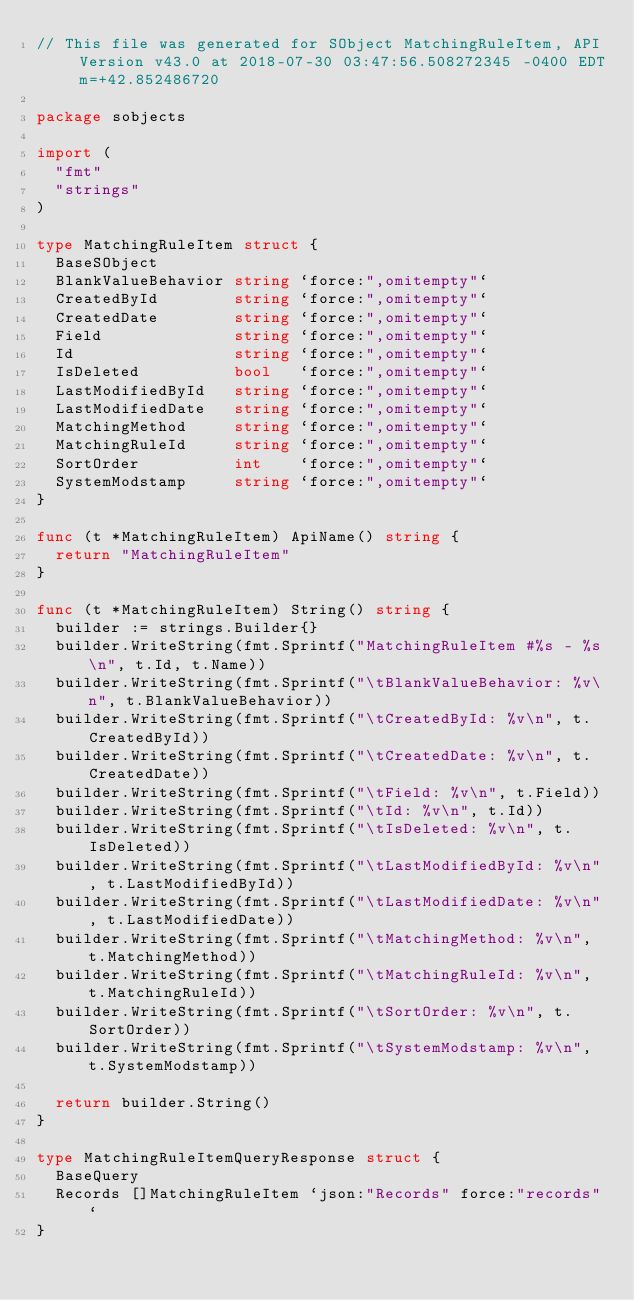Convert code to text. <code><loc_0><loc_0><loc_500><loc_500><_Go_>// This file was generated for SObject MatchingRuleItem, API Version v43.0 at 2018-07-30 03:47:56.508272345 -0400 EDT m=+42.852486720

package sobjects

import (
	"fmt"
	"strings"
)

type MatchingRuleItem struct {
	BaseSObject
	BlankValueBehavior string `force:",omitempty"`
	CreatedById        string `force:",omitempty"`
	CreatedDate        string `force:",omitempty"`
	Field              string `force:",omitempty"`
	Id                 string `force:",omitempty"`
	IsDeleted          bool   `force:",omitempty"`
	LastModifiedById   string `force:",omitempty"`
	LastModifiedDate   string `force:",omitempty"`
	MatchingMethod     string `force:",omitempty"`
	MatchingRuleId     string `force:",omitempty"`
	SortOrder          int    `force:",omitempty"`
	SystemModstamp     string `force:",omitempty"`
}

func (t *MatchingRuleItem) ApiName() string {
	return "MatchingRuleItem"
}

func (t *MatchingRuleItem) String() string {
	builder := strings.Builder{}
	builder.WriteString(fmt.Sprintf("MatchingRuleItem #%s - %s\n", t.Id, t.Name))
	builder.WriteString(fmt.Sprintf("\tBlankValueBehavior: %v\n", t.BlankValueBehavior))
	builder.WriteString(fmt.Sprintf("\tCreatedById: %v\n", t.CreatedById))
	builder.WriteString(fmt.Sprintf("\tCreatedDate: %v\n", t.CreatedDate))
	builder.WriteString(fmt.Sprintf("\tField: %v\n", t.Field))
	builder.WriteString(fmt.Sprintf("\tId: %v\n", t.Id))
	builder.WriteString(fmt.Sprintf("\tIsDeleted: %v\n", t.IsDeleted))
	builder.WriteString(fmt.Sprintf("\tLastModifiedById: %v\n", t.LastModifiedById))
	builder.WriteString(fmt.Sprintf("\tLastModifiedDate: %v\n", t.LastModifiedDate))
	builder.WriteString(fmt.Sprintf("\tMatchingMethod: %v\n", t.MatchingMethod))
	builder.WriteString(fmt.Sprintf("\tMatchingRuleId: %v\n", t.MatchingRuleId))
	builder.WriteString(fmt.Sprintf("\tSortOrder: %v\n", t.SortOrder))
	builder.WriteString(fmt.Sprintf("\tSystemModstamp: %v\n", t.SystemModstamp))

	return builder.String()
}

type MatchingRuleItemQueryResponse struct {
	BaseQuery
	Records []MatchingRuleItem `json:"Records" force:"records"`
}
</code> 